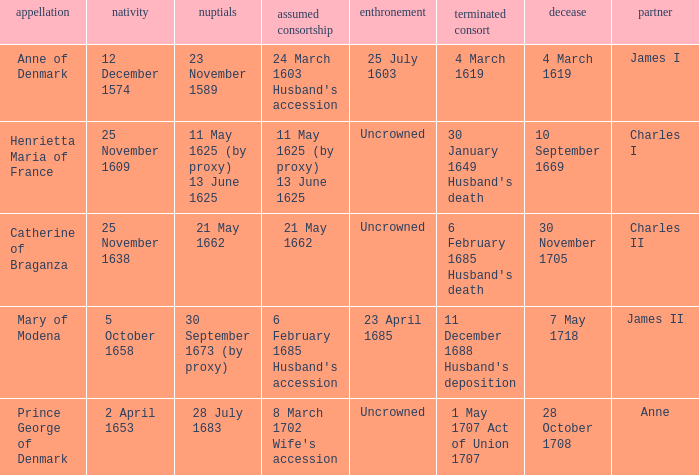Give me the full table as a dictionary. {'header': ['appellation', 'nativity', 'nuptials', 'assumed consortship', 'enthronement', 'terminated consort', 'decease', 'partner'], 'rows': [['Anne of Denmark', '12 December 1574', '23 November 1589', "24 March 1603 Husband's accession", '25 July 1603', '4 March 1619', '4 March 1619', 'James I'], ['Henrietta Maria of France', '25 November 1609', '11 May 1625 (by proxy) 13 June 1625', '11 May 1625 (by proxy) 13 June 1625', 'Uncrowned', "30 January 1649 Husband's death", '10 September 1669', 'Charles I'], ['Catherine of Braganza', '25 November 1638', '21 May 1662', '21 May 1662', 'Uncrowned', "6 February 1685 Husband's death", '30 November 1705', 'Charles II'], ['Mary of Modena', '5 October 1658', '30 September 1673 (by proxy)', "6 February 1685 Husband's accession", '23 April 1685', "11 December 1688 Husband's deposition", '7 May 1718', 'James II'], ['Prince George of Denmark', '2 April 1653', '28 July 1683', "8 March 1702 Wife's accession", 'Uncrowned', '1 May 1707 Act of Union 1707', '28 October 1708', 'Anne']]} When was the date of death for the person married to Charles II? 30 November 1705. 